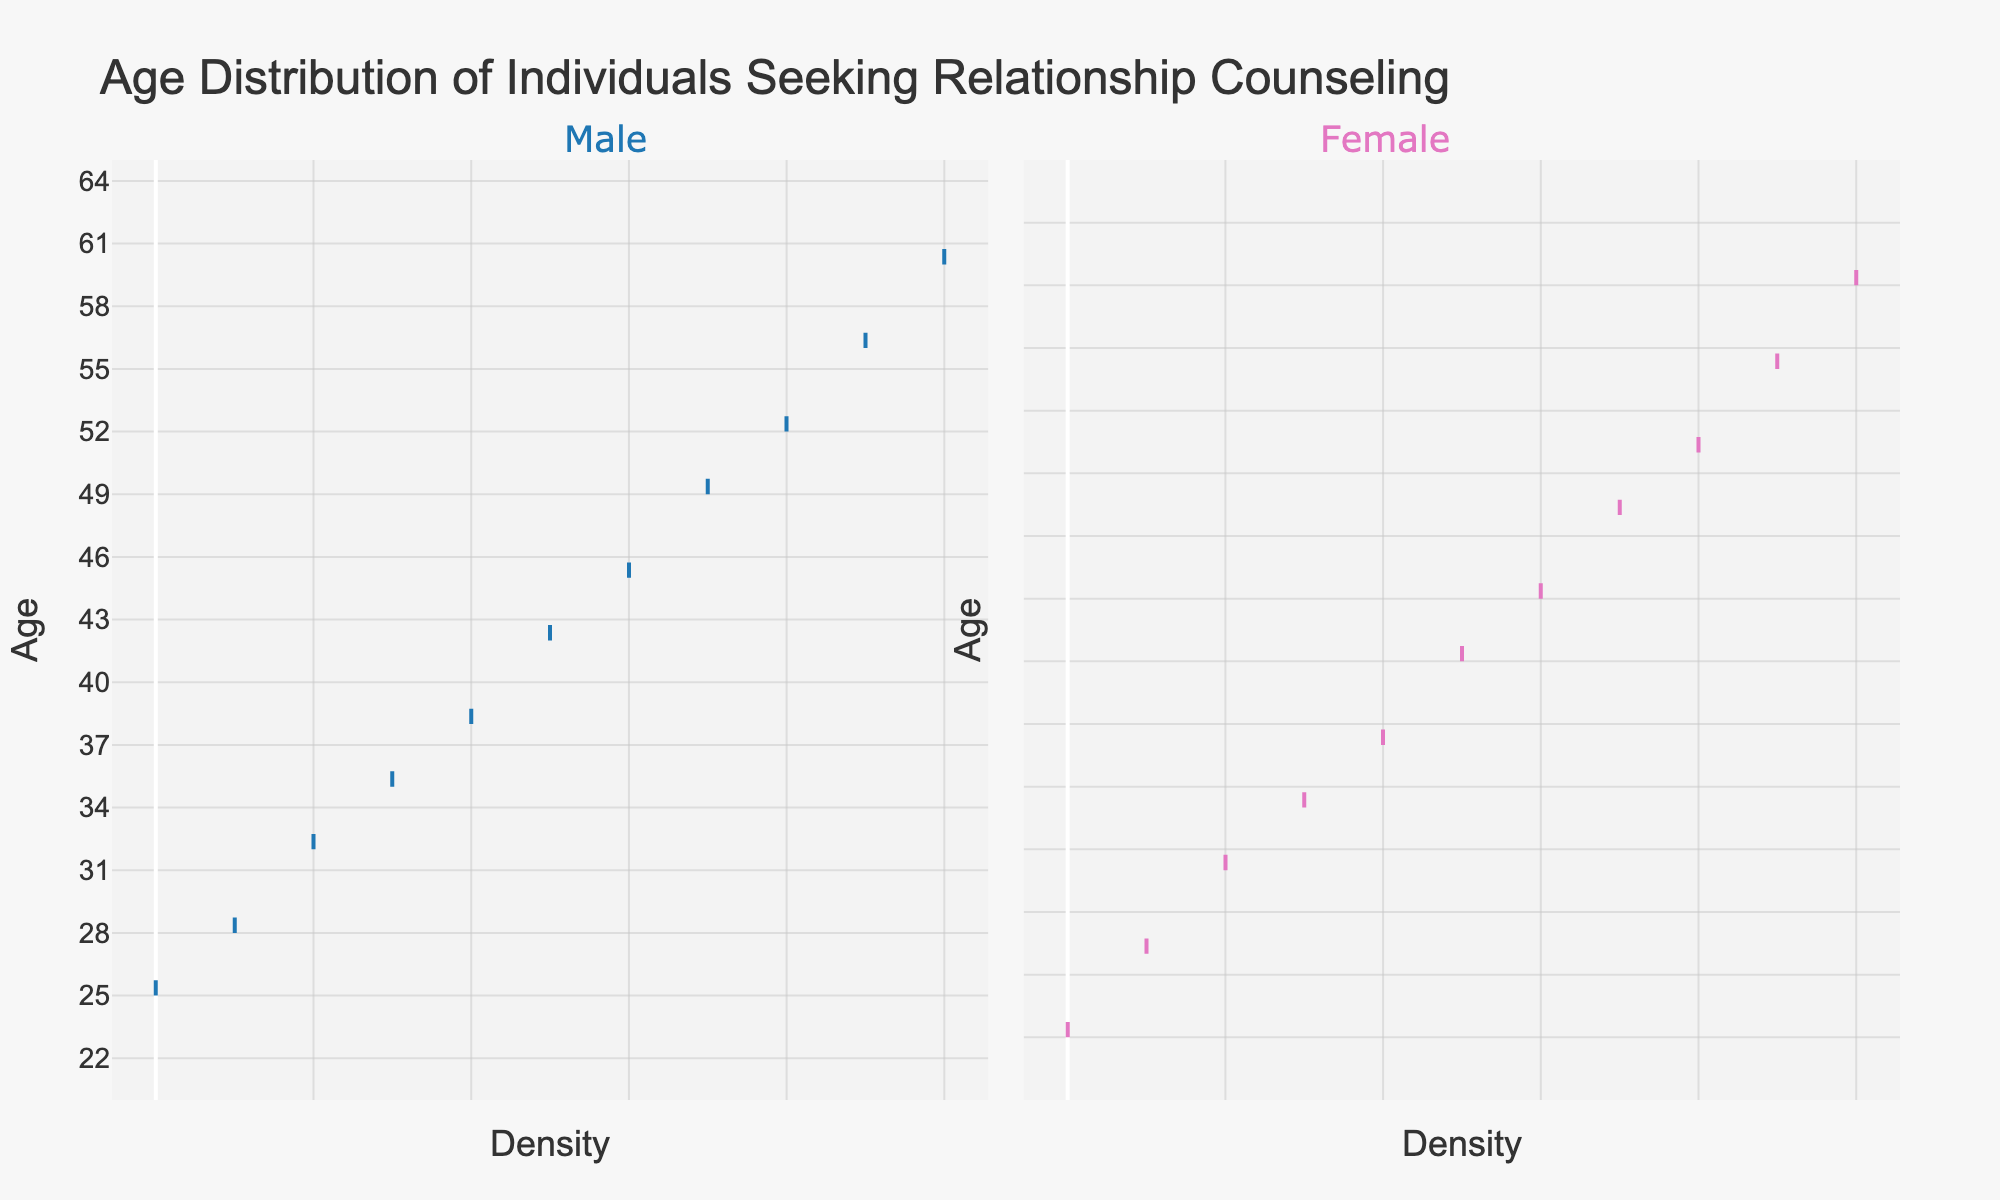What's the title of the plot? The plot title is located at the top and reads, "Age Distribution of Individuals Seeking Relationship Counseling".
Answer: Age Distribution of Individuals Seeking Relationship Counseling What age range does the plot cover? The y-axis of the plot indicates the age range, which spans from 20 to 65 years.
Answer: 20 to 65 years Which gender has the oldest individual seeking relationship counseling? According to the plot, the oldest individuals for both male and female are observed. The female group reaches up to age 59, while the male group reaches up to age 60, therefore the male group has the oldest individual.
Answer: Male At what age do the density plots for males and females start to appear? The density plot for males starts appearing around age 25, whereas the density plot for females starts appearing around age 23, both indicated by the start of the distribution on the y-axis.
Answer: Males: 25, Females: 23 Which gender has a broader age distribution? By visually inspecting the density spread from the bottom to the top of the plot, the age range for males (25-60) is slightly smaller than that for females (23-59), however, the females show a broader age distribution.
Answer: Female What can you deduce about the peak density areas for both genders? The density plots reflect high-density areas by their spread on the x-axis. Both genders appear denser around the ages 30-50, indicating this is the common age range most individuals seeking relationship counseling fall into.
Answer: Around ages 30-50 for both genders How does the density at age 40 compare between males and females? The density at age 40 for both genders can be compared by looking at how wide the distribution is at age 40. Both genders show a peak around this age, indicating a higher concentration of individuals at this age, though the exact comparison of peak height requires closer inspection.
Answer: Similar peak Which gender has more individuals seeking counseling above the age of 50? Observing the density plots, the male distribution has more presence above the age of 50 compared to the female distribution, which tapers off more sharply.
Answer: Male 